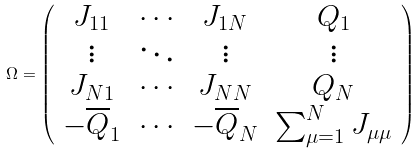<formula> <loc_0><loc_0><loc_500><loc_500>\Omega = \left ( \begin{array} { c c c c } { { J _ { 1 1 } } } & { \cdots } & { { J _ { 1 N } } } & { { Q _ { 1 } } } \\ { \vdots } & { \ddots } & { \vdots } & { \vdots } \\ { { J _ { N 1 } } } & { \cdots } & { { J _ { N N } } } & { { Q _ { N } } } \\ { { - { \overline { Q } } _ { 1 } } } & { \cdots } & { { - { \overline { Q } } _ { N } } } & { { \sum _ { \mu = 1 } ^ { N } J _ { \mu \mu } } } \end{array} \right )</formula> 